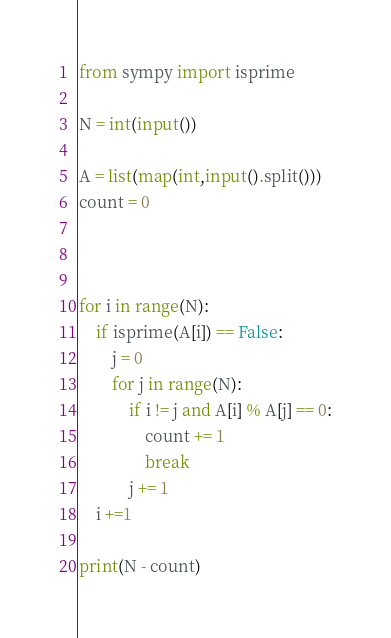Convert code to text. <code><loc_0><loc_0><loc_500><loc_500><_Python_>from sympy import isprime

N = int(input())

A = list(map(int,input().split()))
count = 0



for i in range(N):
    if isprime(A[i]) == False:
        j = 0
        for j in range(N):
            if i != j and A[i] % A[j] == 0:
                count += 1
                break
            j += 1
    i +=1
    
print(N - count)</code> 